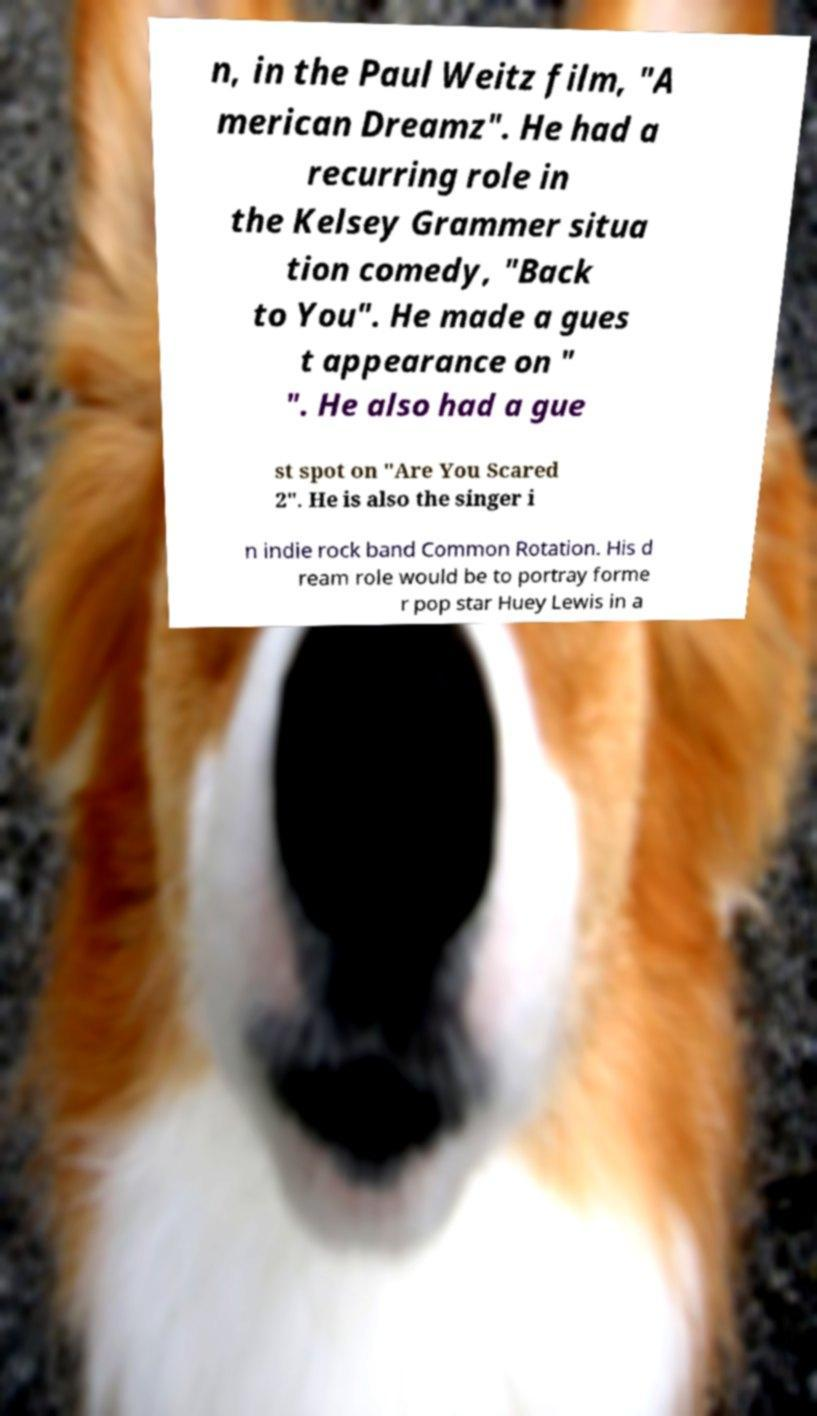Can you read and provide the text displayed in the image?This photo seems to have some interesting text. Can you extract and type it out for me? n, in the Paul Weitz film, "A merican Dreamz". He had a recurring role in the Kelsey Grammer situa tion comedy, "Back to You". He made a gues t appearance on " ". He also had a gue st spot on "Are You Scared 2". He is also the singer i n indie rock band Common Rotation. His d ream role would be to portray forme r pop star Huey Lewis in a 